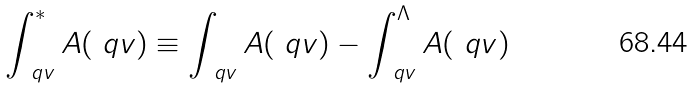Convert formula to latex. <formula><loc_0><loc_0><loc_500><loc_500>\int _ { \ q v } ^ { * } A ( \ q v ) \equiv \int _ { \ q v } A ( \ q v ) - \int _ { \ q v } ^ { \Lambda } A ( \ q v )</formula> 